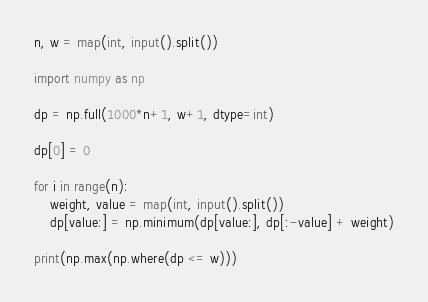Convert code to text. <code><loc_0><loc_0><loc_500><loc_500><_Python_>n, w = map(int, input().split())

import numpy as np 

dp = np.full(1000*n+1, w+1, dtype=int)

dp[0] = 0

for i in range(n):
    weight, value = map(int, input().split())
    dp[value:] = np.minimum(dp[value:], dp[:-value] + weight)

print(np.max(np.where(dp <= w)))</code> 